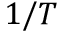<formula> <loc_0><loc_0><loc_500><loc_500>1 / T</formula> 